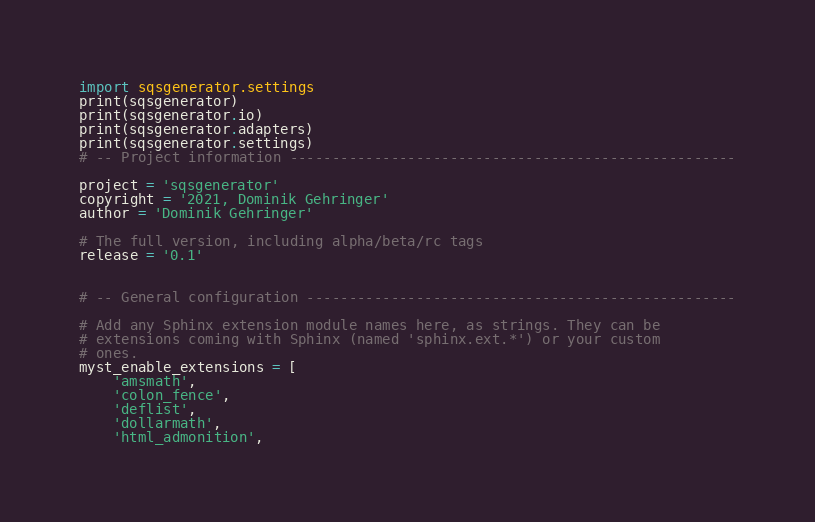Convert code to text. <code><loc_0><loc_0><loc_500><loc_500><_Python_>import sqsgenerator.settings
print(sqsgenerator)
print(sqsgenerator.io)
print(sqsgenerator.adapters)
print(sqsgenerator.settings)
# -- Project information -----------------------------------------------------

project = 'sqsgenerator'
copyright = '2021, Dominik Gehringer'
author = 'Dominik Gehringer'

# The full version, including alpha/beta/rc tags
release = '0.1'


# -- General configuration ---------------------------------------------------

# Add any Sphinx extension module names here, as strings. They can be
# extensions coming with Sphinx (named 'sphinx.ext.*') or your custom
# ones.
myst_enable_extensions = [
    'amsmath',
    'colon_fence',
    'deflist',
    'dollarmath',
    'html_admonition',</code> 